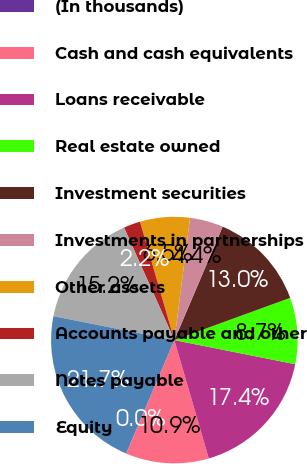<chart> <loc_0><loc_0><loc_500><loc_500><pie_chart><fcel>(In thousands)<fcel>Cash and cash equivalents<fcel>Loans receivable<fcel>Real estate owned<fcel>Investment securities<fcel>Investments in partnerships<fcel>Other assets<fcel>Accounts payable and other<fcel>Notes payable<fcel>Equity<nl><fcel>0.04%<fcel>10.87%<fcel>17.36%<fcel>8.7%<fcel>13.03%<fcel>4.37%<fcel>6.53%<fcel>2.2%<fcel>15.2%<fcel>21.7%<nl></chart> 